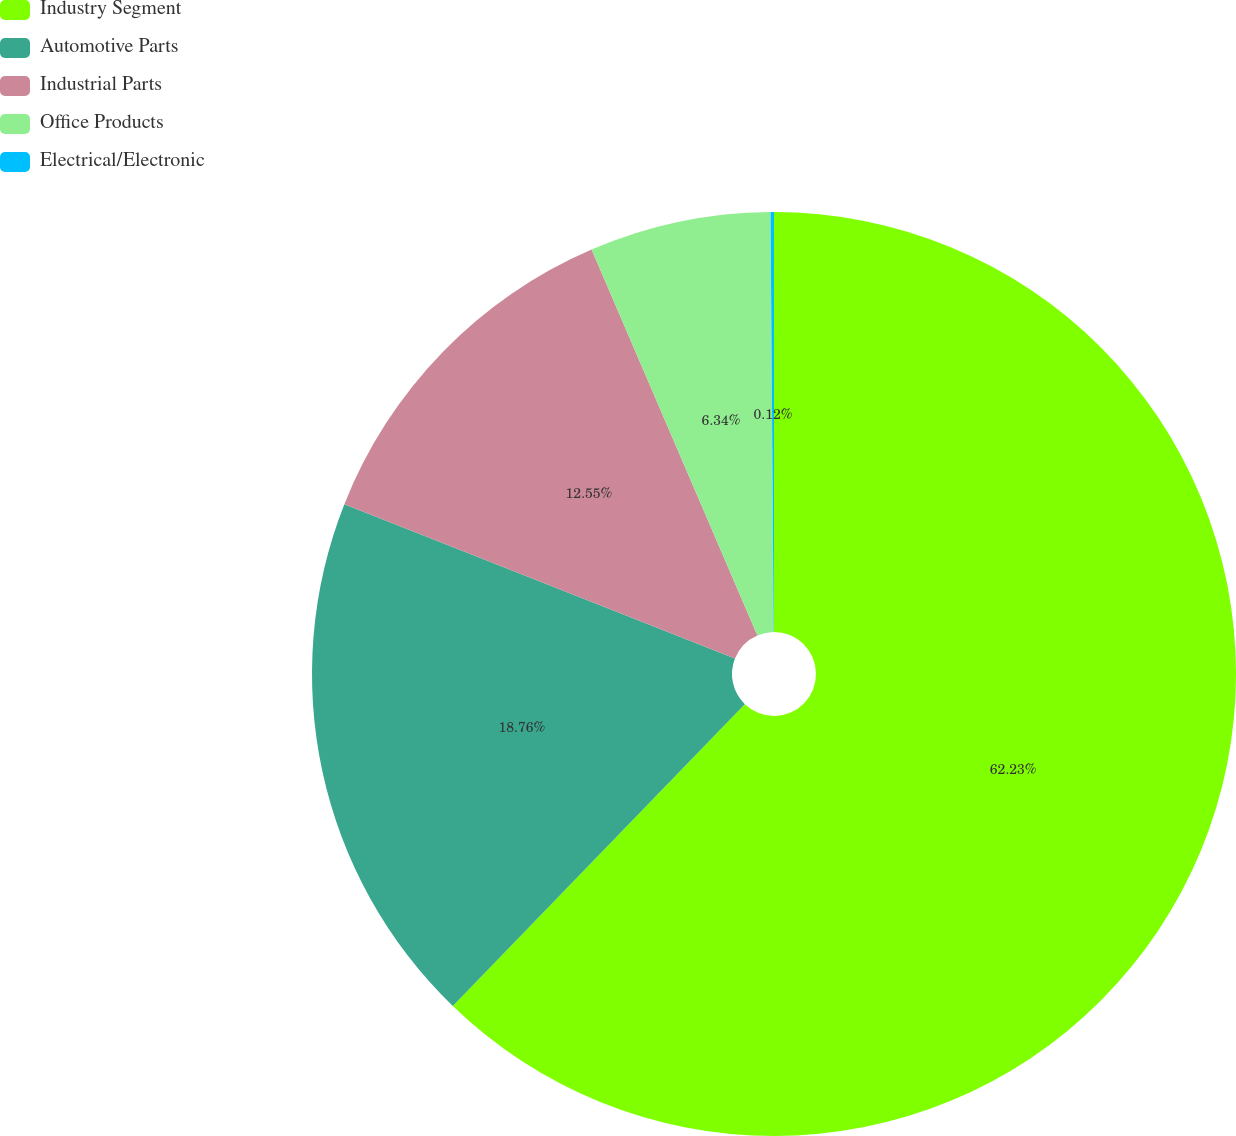<chart> <loc_0><loc_0><loc_500><loc_500><pie_chart><fcel>Industry Segment<fcel>Automotive Parts<fcel>Industrial Parts<fcel>Office Products<fcel>Electrical/Electronic<nl><fcel>62.24%<fcel>18.76%<fcel>12.55%<fcel>6.34%<fcel>0.12%<nl></chart> 